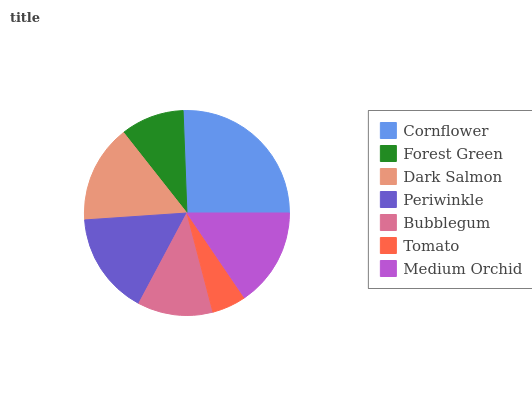Is Tomato the minimum?
Answer yes or no. Yes. Is Cornflower the maximum?
Answer yes or no. Yes. Is Forest Green the minimum?
Answer yes or no. No. Is Forest Green the maximum?
Answer yes or no. No. Is Cornflower greater than Forest Green?
Answer yes or no. Yes. Is Forest Green less than Cornflower?
Answer yes or no. Yes. Is Forest Green greater than Cornflower?
Answer yes or no. No. Is Cornflower less than Forest Green?
Answer yes or no. No. Is Dark Salmon the high median?
Answer yes or no. Yes. Is Dark Salmon the low median?
Answer yes or no. Yes. Is Forest Green the high median?
Answer yes or no. No. Is Tomato the low median?
Answer yes or no. No. 